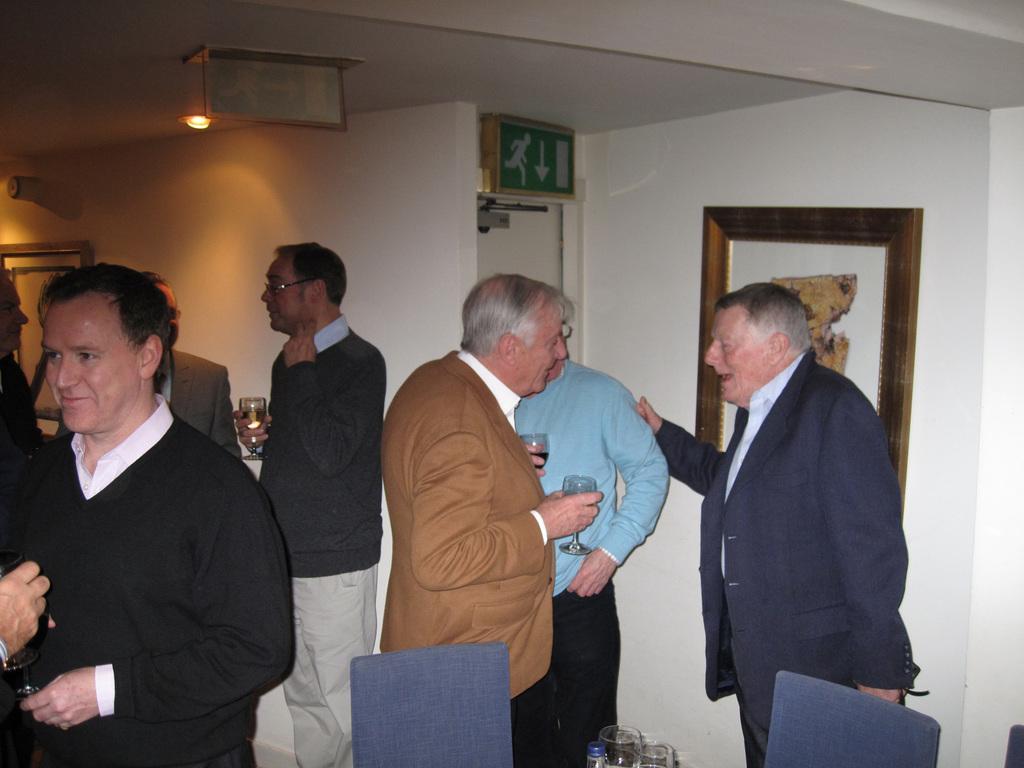Can you describe this image briefly? In the picture we can see few men are standing and talking to each other and behind them, we can see a wall with photo frame and exit door and to the ceiling we can see a light. 